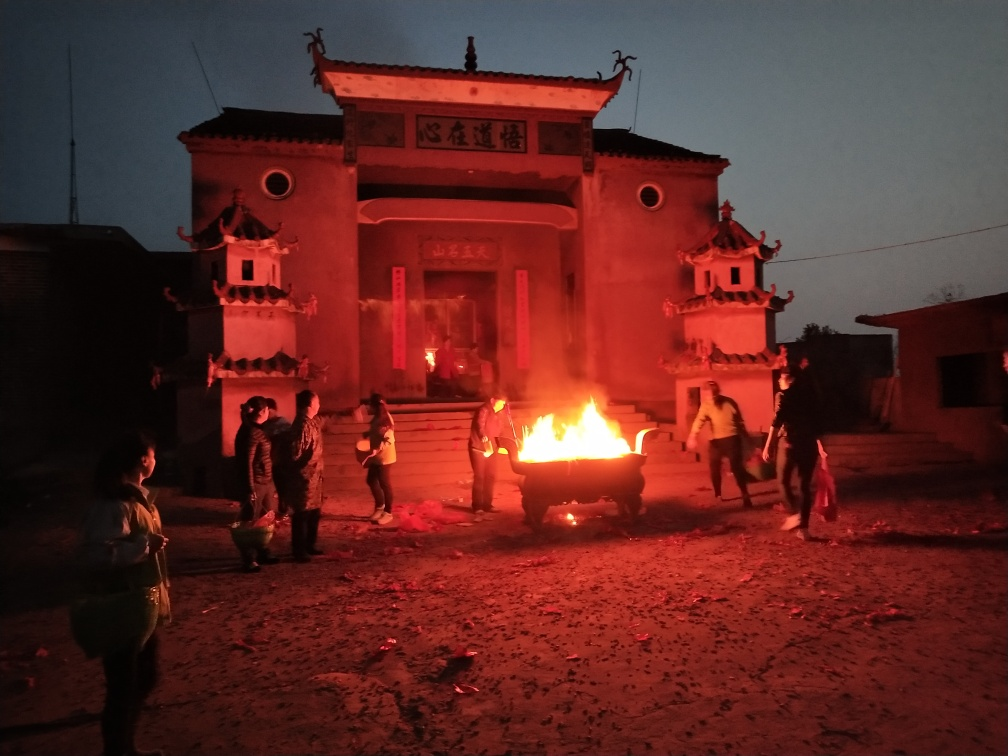What time of day does this image seem to depict, and how does that affect the setting? The image appears to be taken during the evening or night, as the sky is dark, and artificial lighting from the fire illuminates the scene. This timing contributes to the mood by emphasizing the warm light of the fire, creating a stark contrast with the darkness around, and highlighting the communal activity as a beacon in the night. 